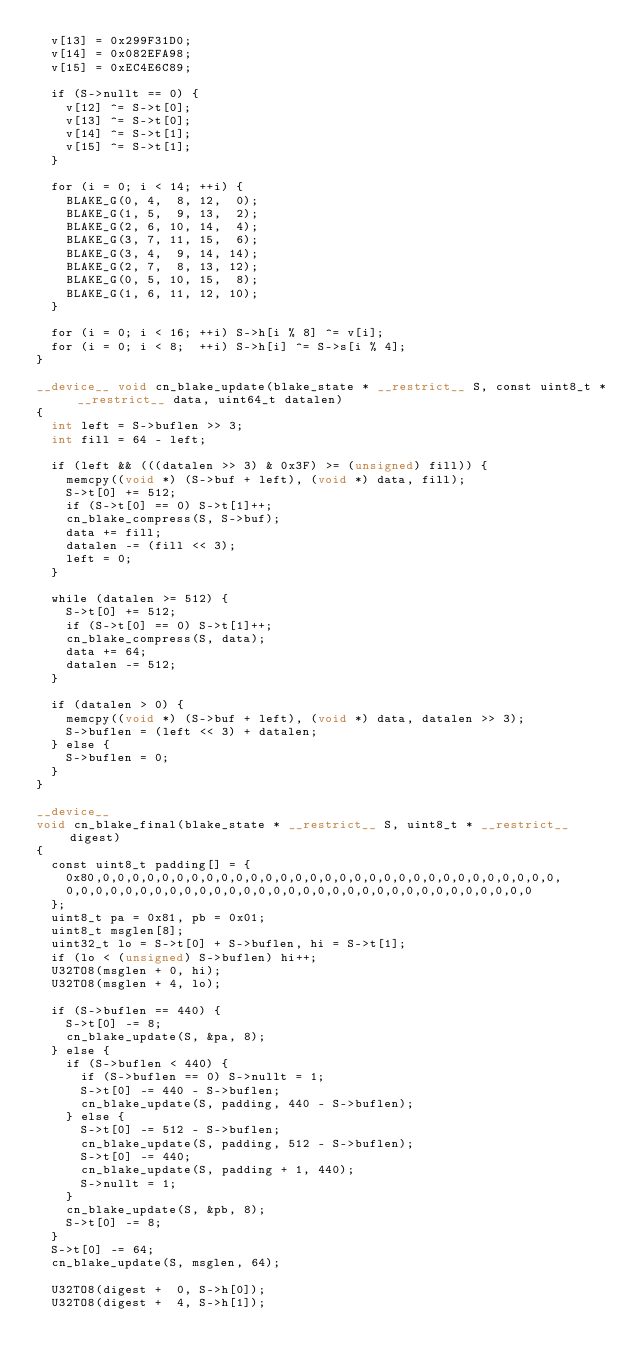<code> <loc_0><loc_0><loc_500><loc_500><_Cuda_>	v[13] = 0x299F31D0;
	v[14] = 0x082EFA98;
	v[15] = 0xEC4E6C89;

	if (S->nullt == 0) {
		v[12] ^= S->t[0];
		v[13] ^= S->t[0];
		v[14] ^= S->t[1];
		v[15] ^= S->t[1];
	}

	for (i = 0; i < 14; ++i) {
		BLAKE_G(0, 4,  8, 12,  0);
		BLAKE_G(1, 5,  9, 13,  2);
		BLAKE_G(2, 6, 10, 14,  4);
		BLAKE_G(3, 7, 11, 15,  6);
		BLAKE_G(3, 4,  9, 14, 14);
		BLAKE_G(2, 7,  8, 13, 12);
		BLAKE_G(0, 5, 10, 15,  8);
		BLAKE_G(1, 6, 11, 12, 10);
	}

	for (i = 0; i < 16; ++i) S->h[i % 8] ^= v[i];
	for (i = 0; i < 8;  ++i) S->h[i] ^= S->s[i % 4];
}

__device__ void cn_blake_update(blake_state * __restrict__ S, const uint8_t * __restrict__ data, uint64_t datalen)
{
	int left = S->buflen >> 3;
	int fill = 64 - left;

	if (left && (((datalen >> 3) & 0x3F) >= (unsigned) fill)) {
		memcpy((void *) (S->buf + left), (void *) data, fill);
		S->t[0] += 512;
		if (S->t[0] == 0) S->t[1]++;
		cn_blake_compress(S, S->buf);
		data += fill;
		datalen -= (fill << 3);
		left = 0;
	}

	while (datalen >= 512) {
		S->t[0] += 512;
		if (S->t[0] == 0) S->t[1]++;
		cn_blake_compress(S, data);
		data += 64;
		datalen -= 512;
	}

	if (datalen > 0) {
		memcpy((void *) (S->buf + left), (void *) data, datalen >> 3);
		S->buflen = (left << 3) + datalen;
	} else {
		S->buflen = 0;
	}
}

__device__
void cn_blake_final(blake_state * __restrict__ S, uint8_t * __restrict__ digest)
{
	const uint8_t padding[] = {
		0x80,0,0,0,0,0,0,0,0,0,0,0,0,0,0,0,0,0,0,0,0,0,0,0,0,0,0,0,0,0,0,0,
		0,0,0,0,0,0,0,0,0,0,0,0,0,0,0,0,0,0,0,0,0,0,0,0,0,0,0,0,0,0,0,0
	};
	uint8_t pa = 0x81, pb = 0x01;
	uint8_t msglen[8];
	uint32_t lo = S->t[0] + S->buflen, hi = S->t[1];
	if (lo < (unsigned) S->buflen) hi++;
	U32TO8(msglen + 0, hi);
	U32TO8(msglen + 4, lo);

	if (S->buflen == 440) {
		S->t[0] -= 8;
		cn_blake_update(S, &pa, 8);
	} else {
		if (S->buflen < 440) {
			if (S->buflen == 0) S->nullt = 1;
			S->t[0] -= 440 - S->buflen;
			cn_blake_update(S, padding, 440 - S->buflen);
		} else {
			S->t[0] -= 512 - S->buflen;
			cn_blake_update(S, padding, 512 - S->buflen);
			S->t[0] -= 440;
			cn_blake_update(S, padding + 1, 440);
			S->nullt = 1;
		}
		cn_blake_update(S, &pb, 8);
		S->t[0] -= 8;
	}
	S->t[0] -= 64;
	cn_blake_update(S, msglen, 64);

	U32TO8(digest +  0, S->h[0]);
	U32TO8(digest +  4, S->h[1]);</code> 